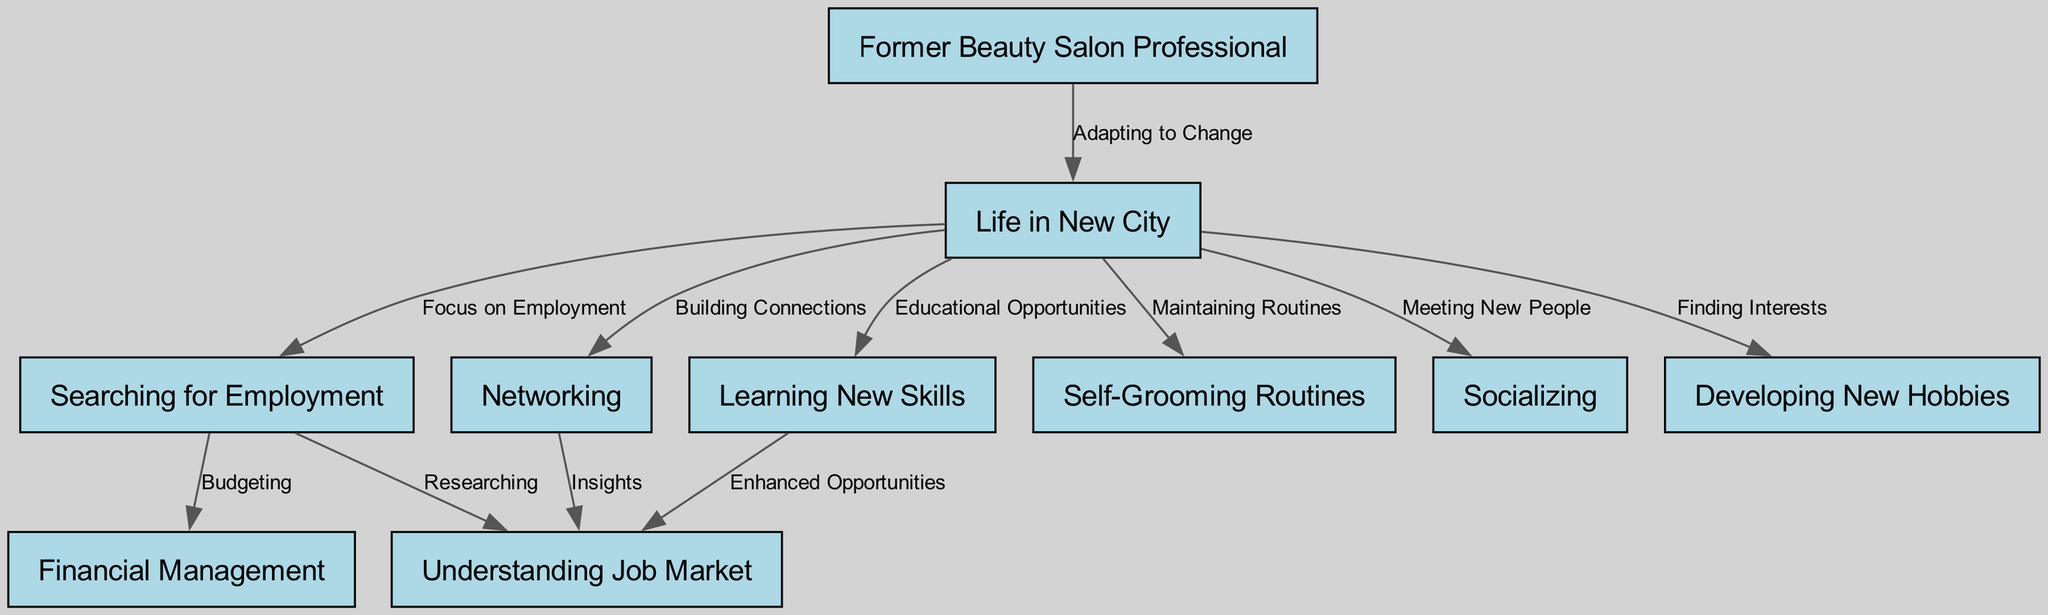What is the total number of nodes in the diagram? The diagram contains 10 nodes. These are: Former Beauty Salon Professional, Life in New City, Searching for Employment, Networking, New Skills, Daily Grooming, Socializing, New Hobbies, Job Market, and Financial Management. Counting them gives a total of 10.
Answer: 10 What does "Life in New City" lead to? The node "Life in New City" leads to 5 nodes: Searching for Employment, Networking, New Skills, Daily Grooming, Socializing, and New Hobbies. This shows the various aspects of life after moving.
Answer: 5 Which node is connected to "Searching for Work"? The "Searching for Work" node connects to two other nodes: Job Market and Financial Management. This suggests that job searchers focus on understanding the job market and managing finances.
Answer: Job Market, Financial Management What relationship exists between "Networking" and "Job Market"? The relationship indicates that "Networking" provides "Insights" regarding the "Job Market." This signifies that networking is a way to gain valuable information about job opportunities.
Answer: Insights How many new skills nodes are indicated to influence the job market? There is 1 node, "New Skills," that is connected to "Job Market," indicating that acquiring new skills enhances opportunities in the job market.
Answer: 1 Which activities are related to a former beauty salon professional maintaining their routines? The activities related to maintaining routines include "Daily Grooming." This indicates that the self-care aspect familiar to beauty professionals continues in their daily life.
Answer: Daily Grooming What is a key focus for a former beauty salon professional in a new city? The key focus is "Searching for Employment," as indicated by the connection that highlights the transition to finding work in a new environment.
Answer: Searching for Employment What does the "Network" node lead to? The "Networking" node leads to the "Job Market," meaning building connections through networking provides insights about job opportunities.
Answer: Job Market What is recommended for adapting to life in a new city? "New Skills" is recommended for adapting to life in a new city, providing educational opportunities to help transition into new roles.
Answer: New Skills 